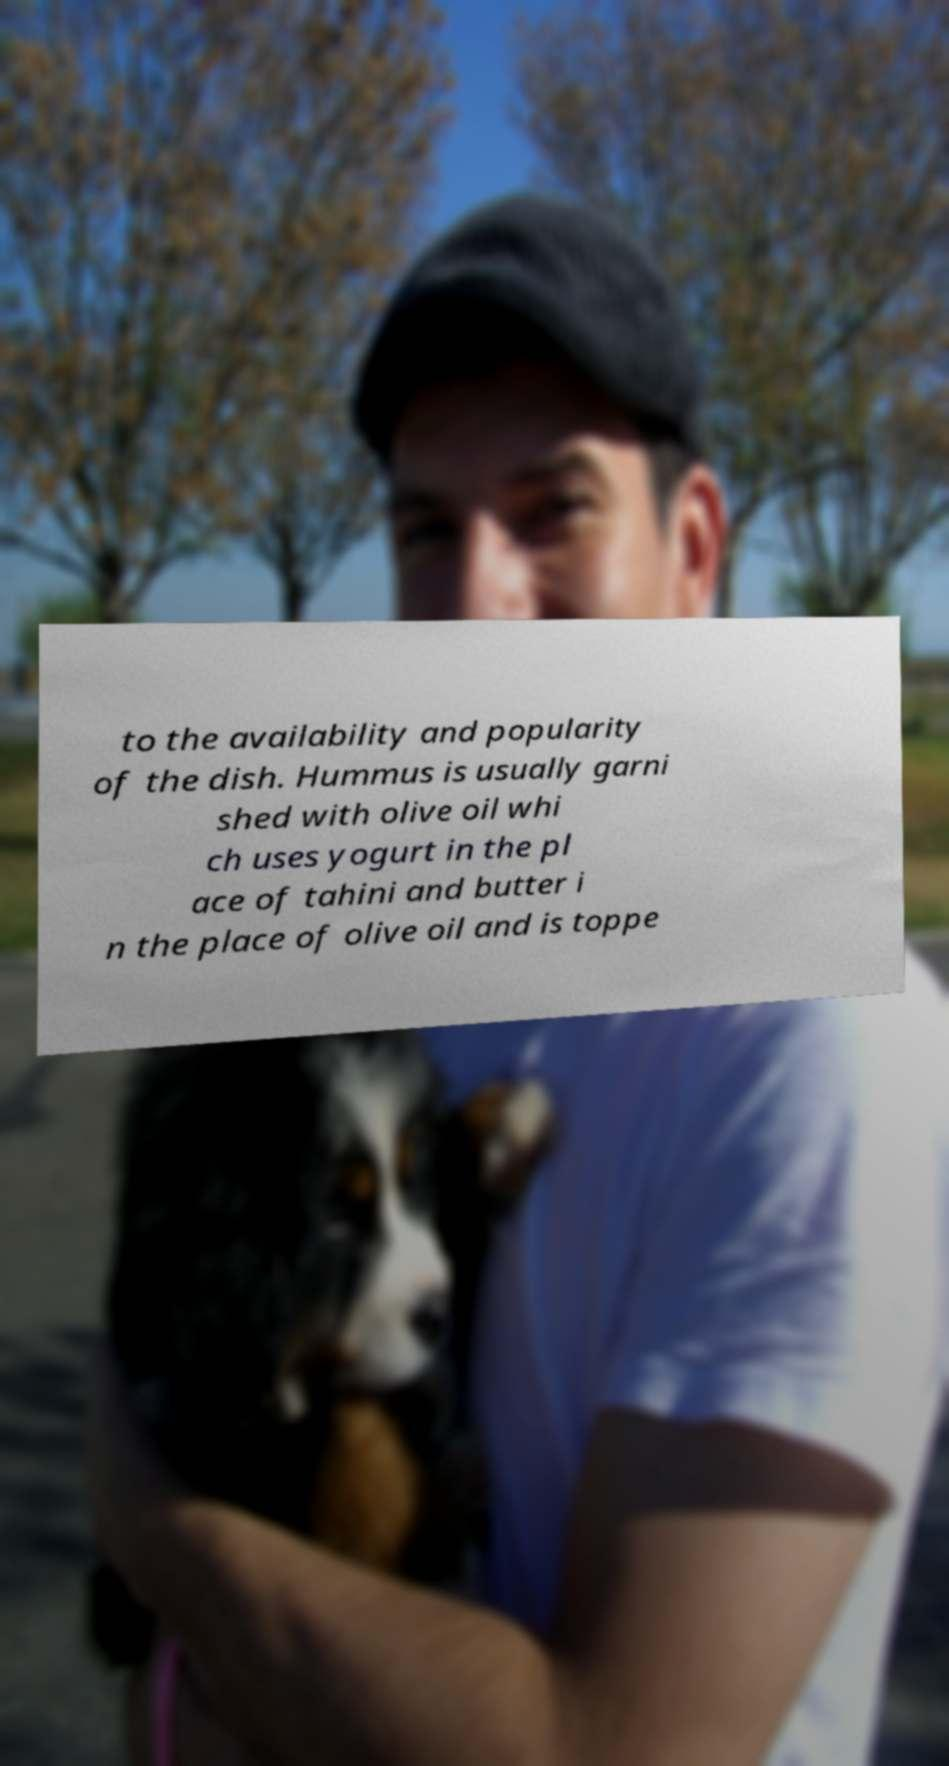I need the written content from this picture converted into text. Can you do that? to the availability and popularity of the dish. Hummus is usually garni shed with olive oil whi ch uses yogurt in the pl ace of tahini and butter i n the place of olive oil and is toppe 